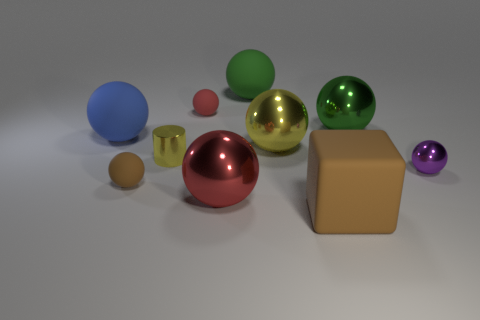What is the material of the brown thing that is the same shape as the purple shiny thing?
Your response must be concise. Rubber. Is the big blue object the same shape as the tiny yellow shiny thing?
Give a very brief answer. No. There is a tiny purple object; how many metallic things are in front of it?
Your response must be concise. 1. There is a big rubber object in front of the large object that is on the left side of the red rubber object; what is its shape?
Your response must be concise. Cube. There is another yellow thing that is made of the same material as the big yellow object; what is its shape?
Offer a very short reply. Cylinder. Do the metallic ball in front of the purple sphere and the rubber ball in front of the tiny yellow cylinder have the same size?
Keep it short and to the point. No. There is a tiny metallic thing to the left of the purple metallic ball; what is its shape?
Offer a very short reply. Cylinder. The metallic cylinder is what color?
Your answer should be very brief. Yellow. There is a red metal sphere; is its size the same as the green shiny sphere on the right side of the big green matte object?
Your response must be concise. Yes. What number of shiny objects are either big red spheres or purple balls?
Provide a short and direct response. 2. 